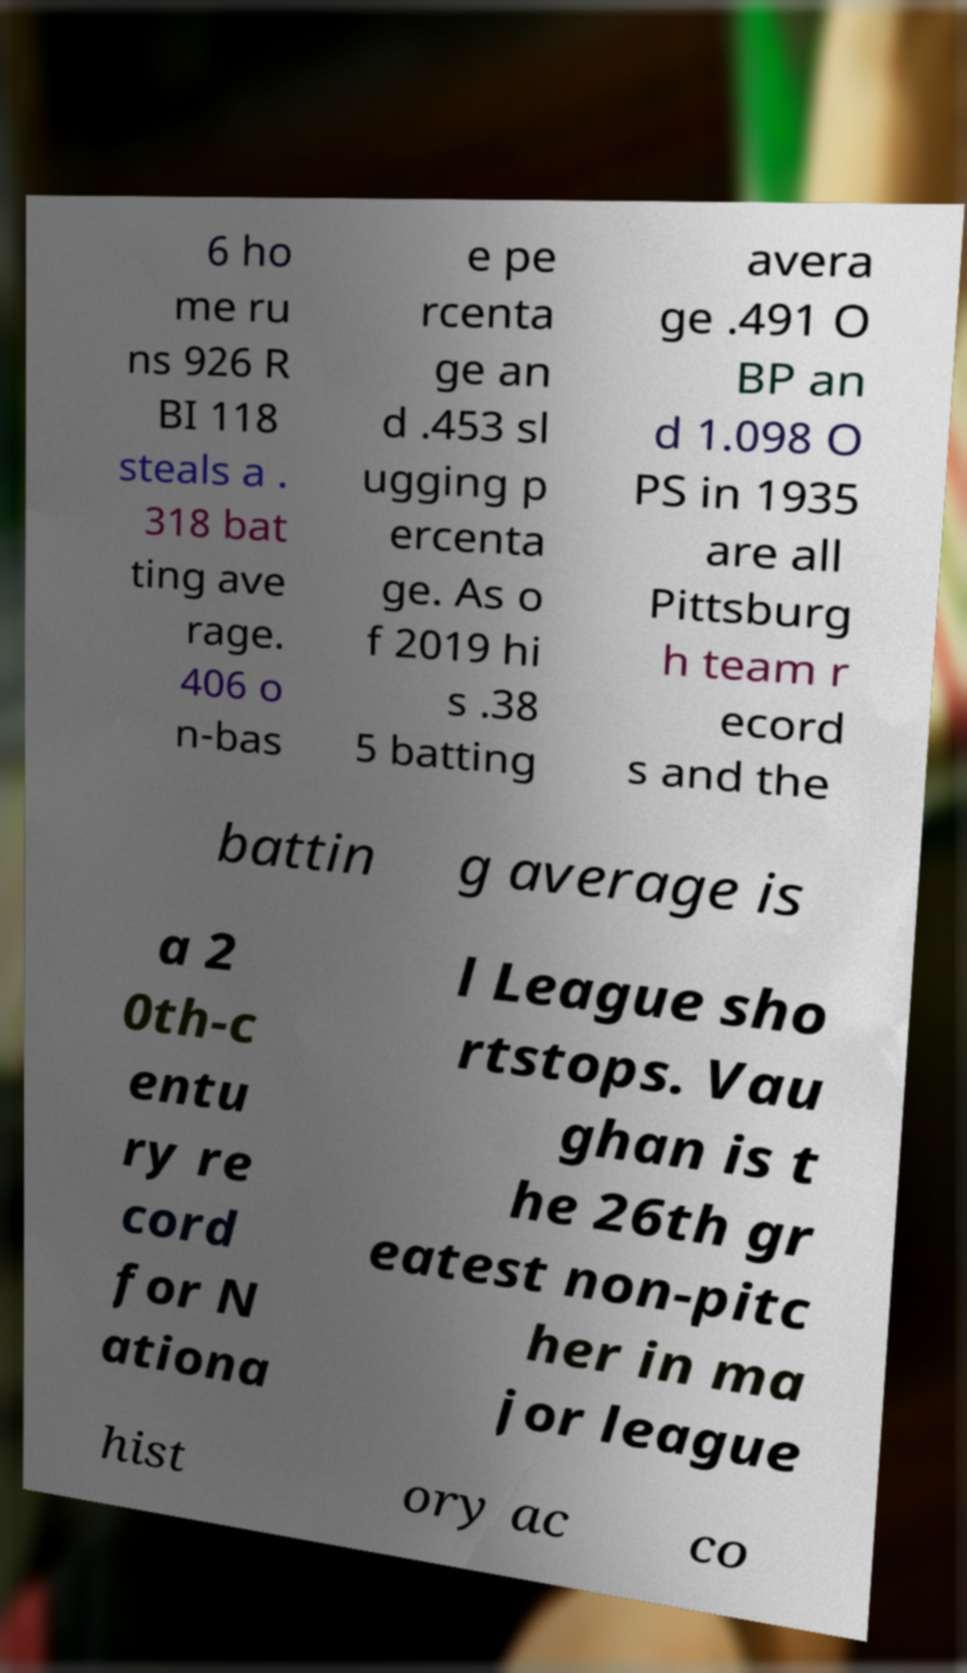Could you extract and type out the text from this image? 6 ho me ru ns 926 R BI 118 steals a . 318 bat ting ave rage. 406 o n-bas e pe rcenta ge an d .453 sl ugging p ercenta ge. As o f 2019 hi s .38 5 batting avera ge .491 O BP an d 1.098 O PS in 1935 are all Pittsburg h team r ecord s and the battin g average is a 2 0th-c entu ry re cord for N ationa l League sho rtstops. Vau ghan is t he 26th gr eatest non-pitc her in ma jor league hist ory ac co 